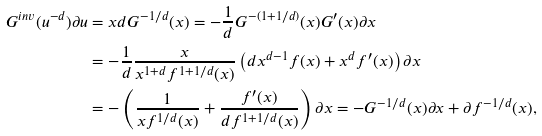Convert formula to latex. <formula><loc_0><loc_0><loc_500><loc_500>G ^ { i n v } ( u ^ { - d } ) \partial u & = x d G ^ { - 1 / d } ( x ) = - \frac { 1 } { d } G ^ { - ( 1 + 1 / d ) } ( x ) G ^ { \prime } ( x ) \partial x \\ & = - \frac { 1 } { d } \frac { x } { x ^ { 1 + d } f ^ { 1 + 1 / d } ( x ) } \left ( d x ^ { d - 1 } f ( x ) + x ^ { d } f ^ { \prime } ( x ) \right ) \partial x \\ & = - \left ( \frac { 1 } { x f ^ { 1 / d } ( x ) } + \frac { f ^ { \prime } ( x ) } { d f ^ { 1 + 1 / d } ( x ) } \right ) \partial x = - G ^ { - 1 / d } ( x ) \partial x + \partial f ^ { - 1 / d } ( x ) ,</formula> 